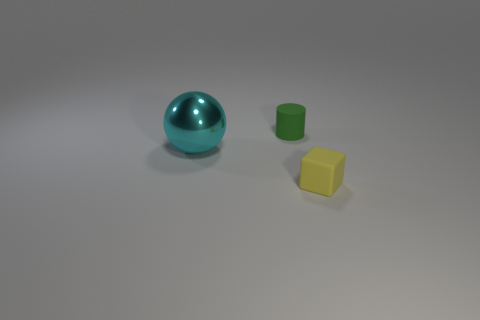Do the tiny object that is behind the small yellow object and the object that is left of the tiny green matte thing have the same material?
Your response must be concise. No. There is a tiny yellow matte object; what shape is it?
Make the answer very short. Cube. Is the number of big metal things left of the small yellow matte cube greater than the number of cyan shiny balls in front of the cyan shiny object?
Ensure brevity in your answer.  Yes. There is a matte thing in front of the large metallic object; does it have the same shape as the object to the left of the green cylinder?
Provide a short and direct response. No. How many other objects are there of the same size as the metal object?
Provide a short and direct response. 0. What size is the matte cylinder?
Offer a terse response. Small. Do the object that is in front of the large cyan metal ball and the small green object have the same material?
Give a very brief answer. Yes. There is a tiny rubber object in front of the metal sphere; does it have the same color as the large shiny object?
Offer a terse response. No. There is a big cyan metallic ball; are there any green things left of it?
Provide a short and direct response. No. There is a object that is both left of the small cube and to the right of the big object; what is its color?
Offer a terse response. Green. 